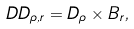<formula> <loc_0><loc_0><loc_500><loc_500>\ D D _ { \rho , r } = D _ { \rho } \times B _ { r } ,</formula> 